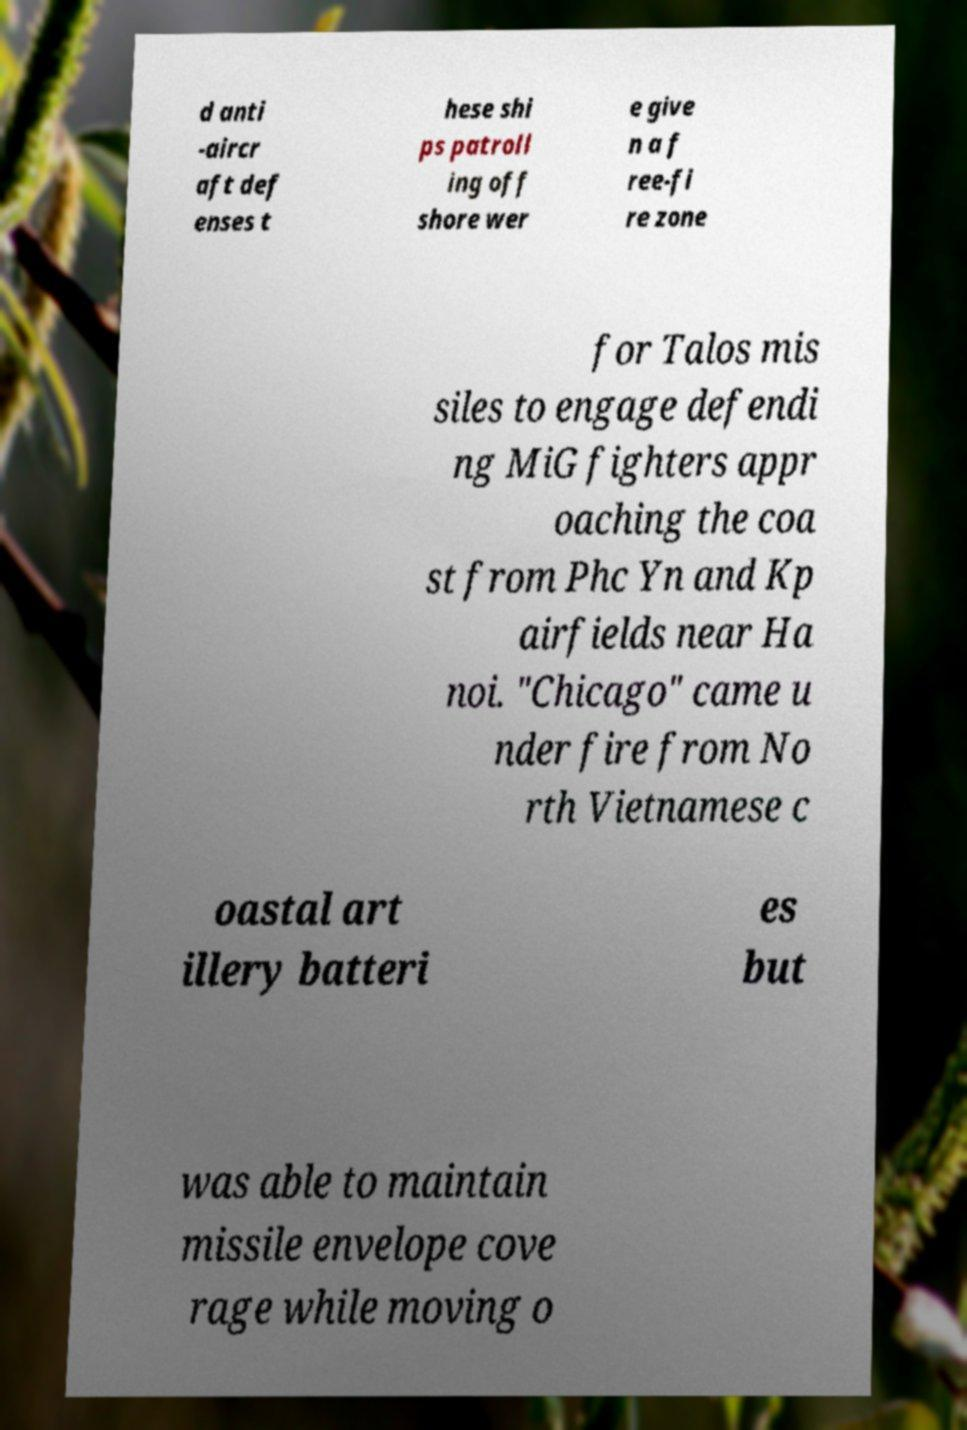I need the written content from this picture converted into text. Can you do that? d anti -aircr aft def enses t hese shi ps patroll ing off shore wer e give n a f ree-fi re zone for Talos mis siles to engage defendi ng MiG fighters appr oaching the coa st from Phc Yn and Kp airfields near Ha noi. "Chicago" came u nder fire from No rth Vietnamese c oastal art illery batteri es but was able to maintain missile envelope cove rage while moving o 